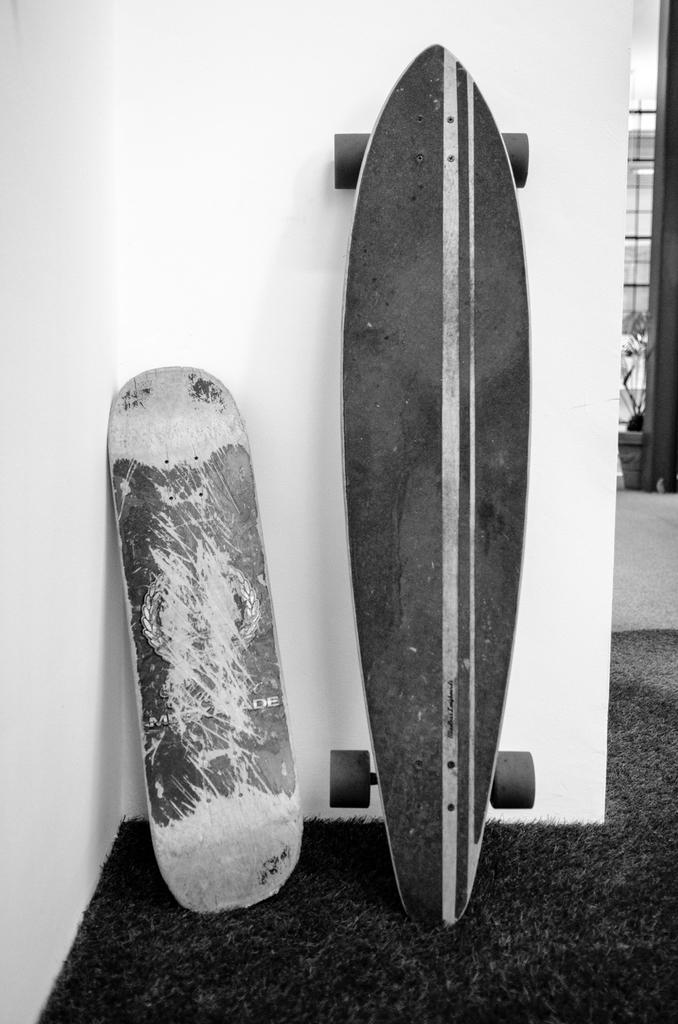What is the color scheme of the image? The image is black and white. How many types of skateboards are visible in the image? There are two different types of skateboards in the image. Where are the skateboards located in the image? One skateboard is on the wall, and the other is on the floor. What can be seen in the background of the image? There is a window and a houseplant in the background of the image. What type of sofa is visible in the image? There is no sofa present in the image. What is the interest of the person sitting on the spot in the image? There is no person or spot visible in the image. 